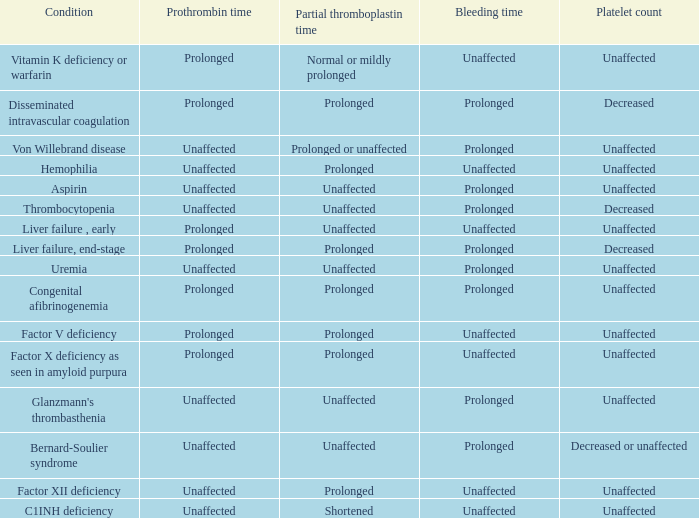Which partial thromboplastin time has a condition of liver failure , early? Unaffected. Would you be able to parse every entry in this table? {'header': ['Condition', 'Prothrombin time', 'Partial thromboplastin time', 'Bleeding time', 'Platelet count'], 'rows': [['Vitamin K deficiency or warfarin', 'Prolonged', 'Normal or mildly prolonged', 'Unaffected', 'Unaffected'], ['Disseminated intravascular coagulation', 'Prolonged', 'Prolonged', 'Prolonged', 'Decreased'], ['Von Willebrand disease', 'Unaffected', 'Prolonged or unaffected', 'Prolonged', 'Unaffected'], ['Hemophilia', 'Unaffected', 'Prolonged', 'Unaffected', 'Unaffected'], ['Aspirin', 'Unaffected', 'Unaffected', 'Prolonged', 'Unaffected'], ['Thrombocytopenia', 'Unaffected', 'Unaffected', 'Prolonged', 'Decreased'], ['Liver failure , early', 'Prolonged', 'Unaffected', 'Unaffected', 'Unaffected'], ['Liver failure, end-stage', 'Prolonged', 'Prolonged', 'Prolonged', 'Decreased'], ['Uremia', 'Unaffected', 'Unaffected', 'Prolonged', 'Unaffected'], ['Congenital afibrinogenemia', 'Prolonged', 'Prolonged', 'Prolonged', 'Unaffected'], ['Factor V deficiency', 'Prolonged', 'Prolonged', 'Unaffected', 'Unaffected'], ['Factor X deficiency as seen in amyloid purpura', 'Prolonged', 'Prolonged', 'Unaffected', 'Unaffected'], ["Glanzmann's thrombasthenia", 'Unaffected', 'Unaffected', 'Prolonged', 'Unaffected'], ['Bernard-Soulier syndrome', 'Unaffected', 'Unaffected', 'Prolonged', 'Decreased or unaffected'], ['Factor XII deficiency', 'Unaffected', 'Prolonged', 'Unaffected', 'Unaffected'], ['C1INH deficiency', 'Unaffected', 'Shortened', 'Unaffected', 'Unaffected']]} 